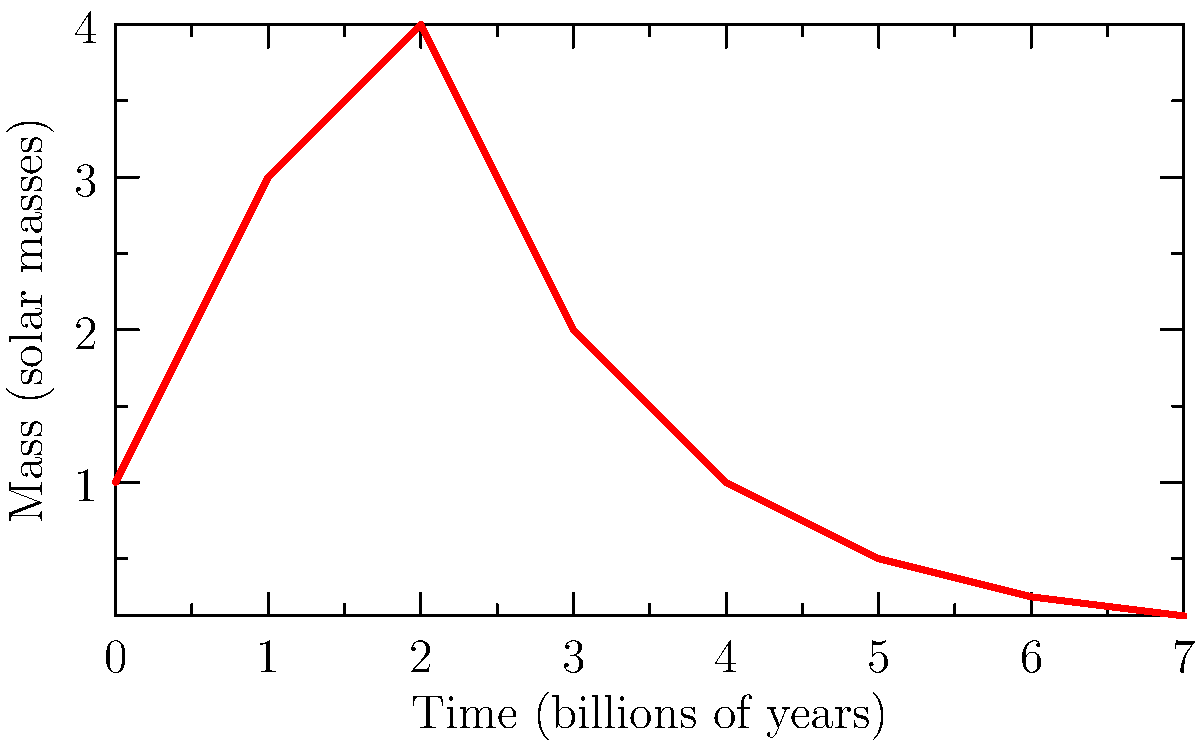As a corporate lawyer, you understand the importance of strategic planning. In the context of a star's life cycle, which phase represents the longest and most stable period, similar to a successful mid-career professional? Let's break down the life cycle of a star step-by-step:

1. Nebula: The star begins as a cloud of gas and dust, much like the early stages of a career or business plan.

2. Protostar: As gravity pulls the nebula together, it forms a protostar, analogous to the formative years of a professional.

3. Main Sequence: This is the longest and most stable phase of a star's life, where it burns hydrogen in its core. For our sun, this phase lasts about 10 billion years. This is similar to the peak of a successful career.

4. Red Giant: As the star exhausts its hydrogen, it expands and cools, becoming a red giant. This could be compared to the later stages of a career where one's influence expands but energy may decrease.

5. Final Stages: Depending on the star's mass, it will end as either:
   a) White Dwarf: For stars like our sun, they shed outer layers and become a small, dense white dwarf.
   b) Black Hole: For very massive stars, they may collapse into a black hole after a supernova explosion.

The Main Sequence phase is the longest and most stable, representing the prime of a star's "career." During this time, the star maintains a balance between gravity and outward pressure from fusion reactions, much like a successful professional balances various aspects of their career.
Answer: Main Sequence 